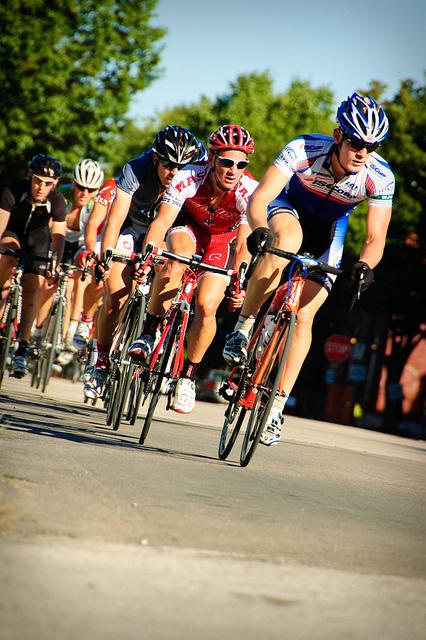Are they learning?
Keep it brief. Yes. What are they riding?
Short answer required. Bicycles. When was the pic taken?
Give a very brief answer. Daytime. 